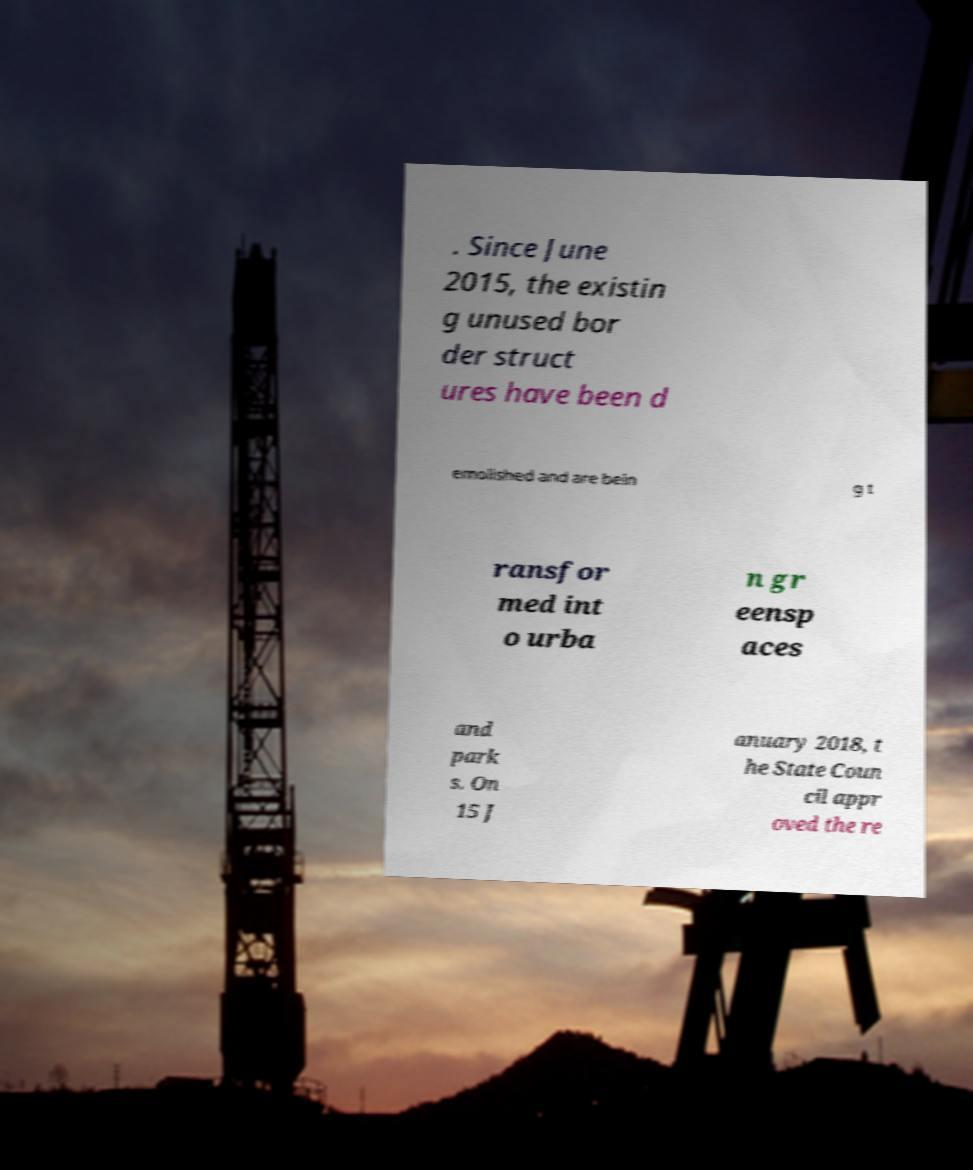Please identify and transcribe the text found in this image. . Since June 2015, the existin g unused bor der struct ures have been d emolished and are bein g t ransfor med int o urba n gr eensp aces and park s. On 15 J anuary 2018, t he State Coun cil appr oved the re 